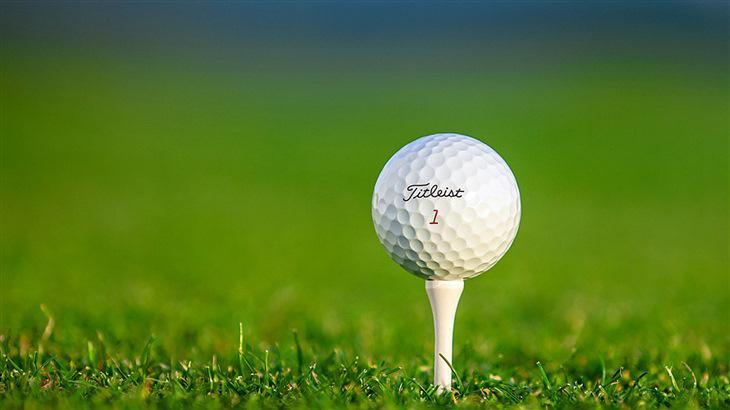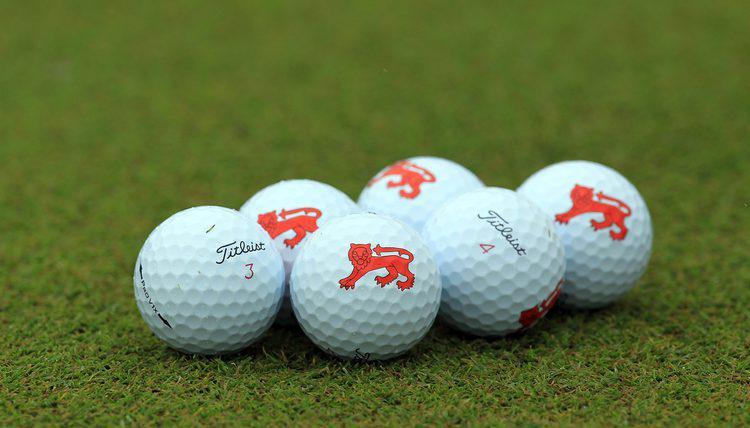The first image is the image on the left, the second image is the image on the right. Given the left and right images, does the statement "There are at least seven golf balls." hold true? Answer yes or no. Yes. 